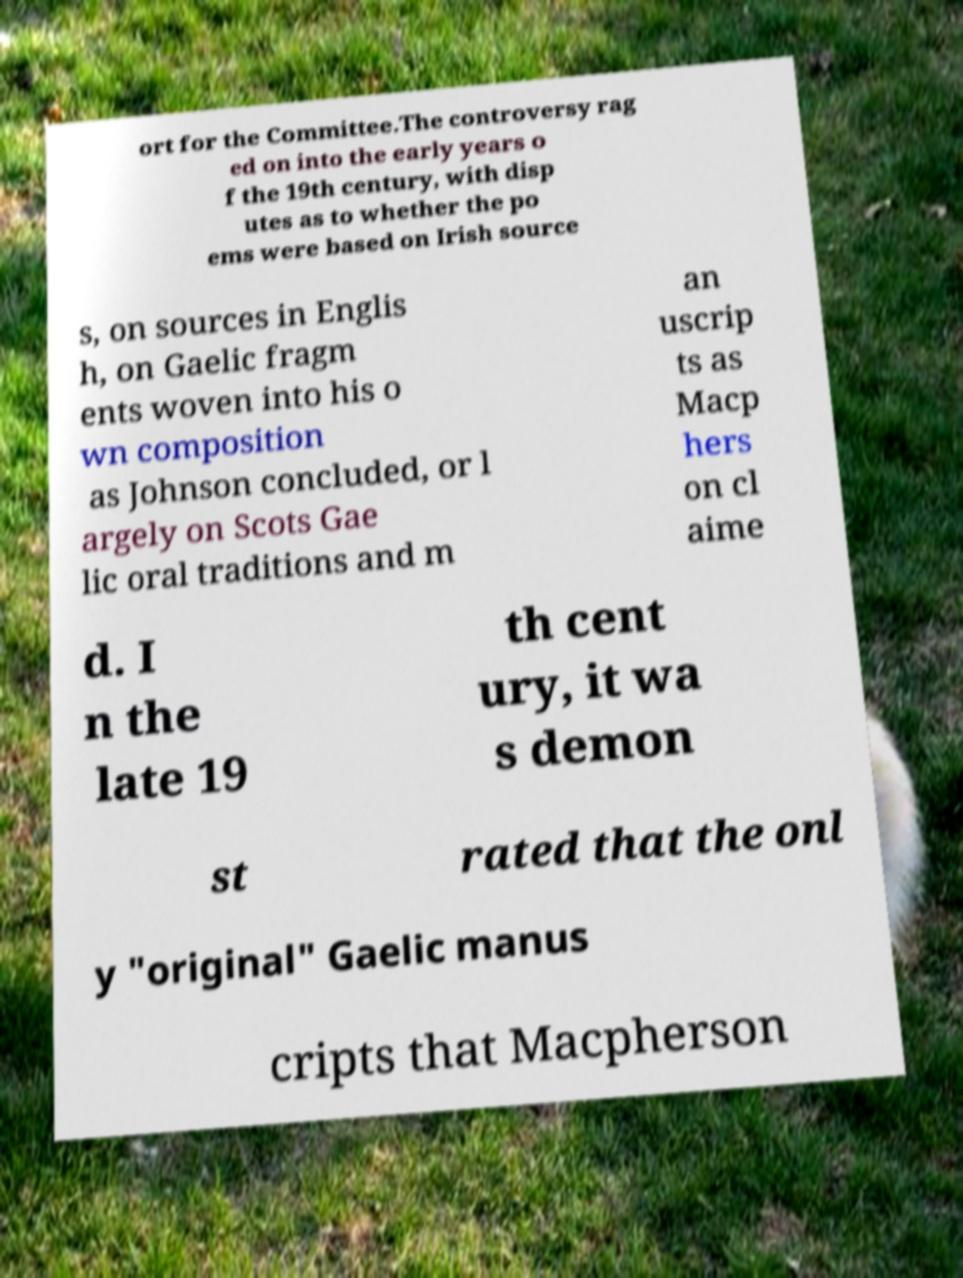There's text embedded in this image that I need extracted. Can you transcribe it verbatim? ort for the Committee.The controversy rag ed on into the early years o f the 19th century, with disp utes as to whether the po ems were based on Irish source s, on sources in Englis h, on Gaelic fragm ents woven into his o wn composition as Johnson concluded, or l argely on Scots Gae lic oral traditions and m an uscrip ts as Macp hers on cl aime d. I n the late 19 th cent ury, it wa s demon st rated that the onl y "original" Gaelic manus cripts that Macpherson 